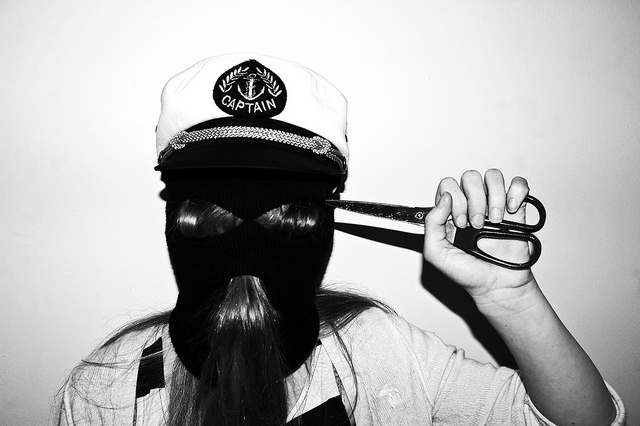Describe the objects in this image and their specific colors. I can see people in lightgray, black, darkgray, and gray tones and scissors in lightgray, black, gray, and darkgray tones in this image. 